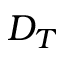Convert formula to latex. <formula><loc_0><loc_0><loc_500><loc_500>D _ { T }</formula> 